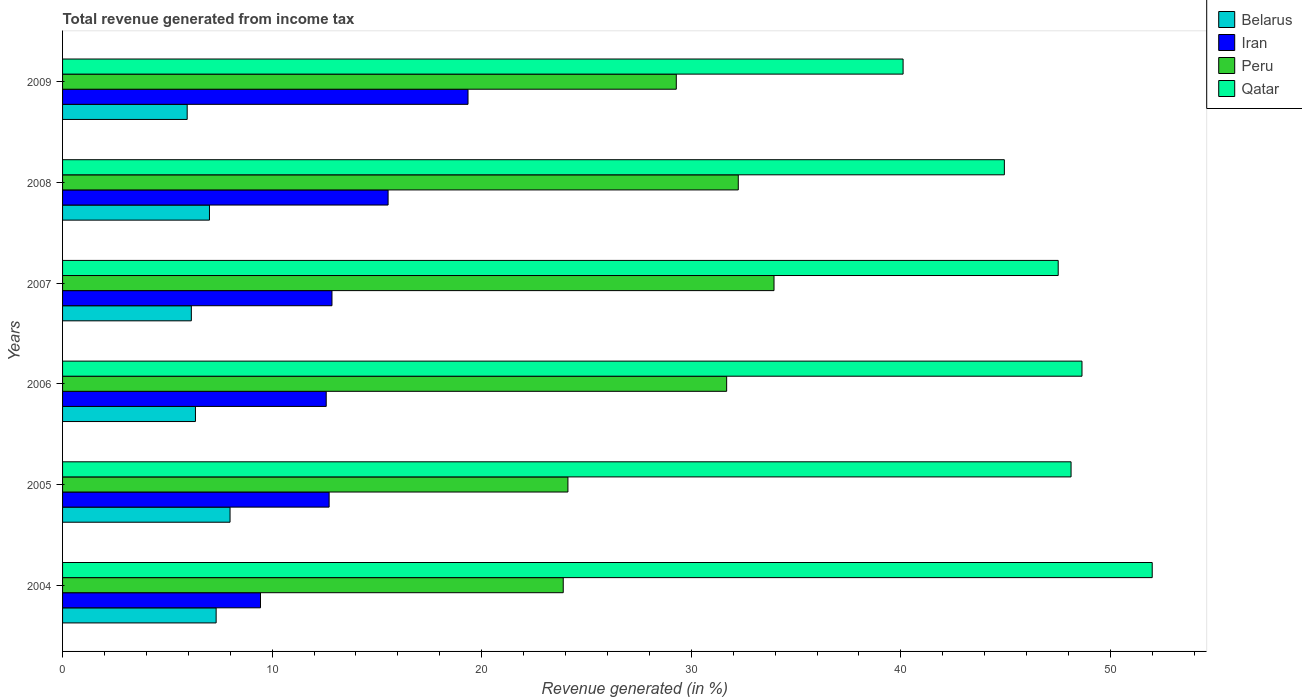How many different coloured bars are there?
Keep it short and to the point. 4. Are the number of bars on each tick of the Y-axis equal?
Provide a short and direct response. Yes. How many bars are there on the 5th tick from the bottom?
Your answer should be compact. 4. In how many cases, is the number of bars for a given year not equal to the number of legend labels?
Provide a succinct answer. 0. What is the total revenue generated in Qatar in 2007?
Provide a short and direct response. 47.51. Across all years, what is the maximum total revenue generated in Peru?
Your response must be concise. 33.95. Across all years, what is the minimum total revenue generated in Iran?
Provide a succinct answer. 9.45. In which year was the total revenue generated in Belarus minimum?
Give a very brief answer. 2009. What is the total total revenue generated in Iran in the graph?
Provide a short and direct response. 82.48. What is the difference between the total revenue generated in Qatar in 2007 and that in 2008?
Make the answer very short. 2.57. What is the difference between the total revenue generated in Peru in 2006 and the total revenue generated in Belarus in 2009?
Ensure brevity in your answer.  25.74. What is the average total revenue generated in Qatar per year?
Offer a terse response. 46.89. In the year 2006, what is the difference between the total revenue generated in Peru and total revenue generated in Belarus?
Offer a very short reply. 25.35. In how many years, is the total revenue generated in Iran greater than 12 %?
Your answer should be compact. 5. What is the ratio of the total revenue generated in Iran in 2004 to that in 2006?
Ensure brevity in your answer.  0.75. What is the difference between the highest and the second highest total revenue generated in Peru?
Offer a very short reply. 1.71. What is the difference between the highest and the lowest total revenue generated in Qatar?
Make the answer very short. 11.89. In how many years, is the total revenue generated in Belarus greater than the average total revenue generated in Belarus taken over all years?
Keep it short and to the point. 3. Is it the case that in every year, the sum of the total revenue generated in Peru and total revenue generated in Qatar is greater than the sum of total revenue generated in Iran and total revenue generated in Belarus?
Ensure brevity in your answer.  Yes. What does the 2nd bar from the top in 2006 represents?
Offer a very short reply. Peru. How many bars are there?
Keep it short and to the point. 24. Are all the bars in the graph horizontal?
Your answer should be compact. Yes. What is the difference between two consecutive major ticks on the X-axis?
Your answer should be compact. 10. Are the values on the major ticks of X-axis written in scientific E-notation?
Keep it short and to the point. No. Does the graph contain grids?
Your response must be concise. No. Where does the legend appear in the graph?
Your answer should be compact. Top right. What is the title of the graph?
Make the answer very short. Total revenue generated from income tax. Does "Togo" appear as one of the legend labels in the graph?
Provide a succinct answer. No. What is the label or title of the X-axis?
Keep it short and to the point. Revenue generated (in %). What is the Revenue generated (in %) of Belarus in 2004?
Your answer should be very brief. 7.33. What is the Revenue generated (in %) in Iran in 2004?
Offer a terse response. 9.45. What is the Revenue generated (in %) in Peru in 2004?
Your answer should be very brief. 23.89. What is the Revenue generated (in %) of Qatar in 2004?
Your answer should be compact. 52. What is the Revenue generated (in %) of Belarus in 2005?
Your answer should be very brief. 7.99. What is the Revenue generated (in %) of Iran in 2005?
Provide a succinct answer. 12.72. What is the Revenue generated (in %) of Peru in 2005?
Make the answer very short. 24.11. What is the Revenue generated (in %) in Qatar in 2005?
Your response must be concise. 48.12. What is the Revenue generated (in %) in Belarus in 2006?
Make the answer very short. 6.34. What is the Revenue generated (in %) in Iran in 2006?
Provide a succinct answer. 12.58. What is the Revenue generated (in %) in Peru in 2006?
Your response must be concise. 31.69. What is the Revenue generated (in %) of Qatar in 2006?
Keep it short and to the point. 48.64. What is the Revenue generated (in %) in Belarus in 2007?
Your response must be concise. 6.15. What is the Revenue generated (in %) of Iran in 2007?
Make the answer very short. 12.86. What is the Revenue generated (in %) of Peru in 2007?
Offer a very short reply. 33.95. What is the Revenue generated (in %) in Qatar in 2007?
Your answer should be very brief. 47.51. What is the Revenue generated (in %) in Belarus in 2008?
Ensure brevity in your answer.  7.01. What is the Revenue generated (in %) in Iran in 2008?
Offer a terse response. 15.53. What is the Revenue generated (in %) of Peru in 2008?
Your answer should be compact. 32.24. What is the Revenue generated (in %) of Qatar in 2008?
Provide a short and direct response. 44.94. What is the Revenue generated (in %) in Belarus in 2009?
Provide a succinct answer. 5.95. What is the Revenue generated (in %) of Iran in 2009?
Offer a terse response. 19.35. What is the Revenue generated (in %) of Peru in 2009?
Your answer should be compact. 29.29. What is the Revenue generated (in %) in Qatar in 2009?
Your answer should be very brief. 40.11. Across all years, what is the maximum Revenue generated (in %) of Belarus?
Keep it short and to the point. 7.99. Across all years, what is the maximum Revenue generated (in %) of Iran?
Your response must be concise. 19.35. Across all years, what is the maximum Revenue generated (in %) in Peru?
Offer a terse response. 33.95. Across all years, what is the maximum Revenue generated (in %) of Qatar?
Ensure brevity in your answer.  52. Across all years, what is the minimum Revenue generated (in %) in Belarus?
Keep it short and to the point. 5.95. Across all years, what is the minimum Revenue generated (in %) in Iran?
Give a very brief answer. 9.45. Across all years, what is the minimum Revenue generated (in %) in Peru?
Ensure brevity in your answer.  23.89. Across all years, what is the minimum Revenue generated (in %) of Qatar?
Your answer should be compact. 40.11. What is the total Revenue generated (in %) in Belarus in the graph?
Ensure brevity in your answer.  40.76. What is the total Revenue generated (in %) in Iran in the graph?
Ensure brevity in your answer.  82.48. What is the total Revenue generated (in %) of Peru in the graph?
Make the answer very short. 175.17. What is the total Revenue generated (in %) in Qatar in the graph?
Ensure brevity in your answer.  281.32. What is the difference between the Revenue generated (in %) of Belarus in 2004 and that in 2005?
Provide a short and direct response. -0.66. What is the difference between the Revenue generated (in %) in Iran in 2004 and that in 2005?
Keep it short and to the point. -3.27. What is the difference between the Revenue generated (in %) in Peru in 2004 and that in 2005?
Ensure brevity in your answer.  -0.22. What is the difference between the Revenue generated (in %) in Qatar in 2004 and that in 2005?
Give a very brief answer. 3.87. What is the difference between the Revenue generated (in %) of Belarus in 2004 and that in 2006?
Your answer should be compact. 0.99. What is the difference between the Revenue generated (in %) in Iran in 2004 and that in 2006?
Offer a terse response. -3.14. What is the difference between the Revenue generated (in %) in Peru in 2004 and that in 2006?
Provide a short and direct response. -7.8. What is the difference between the Revenue generated (in %) in Qatar in 2004 and that in 2006?
Keep it short and to the point. 3.35. What is the difference between the Revenue generated (in %) of Belarus in 2004 and that in 2007?
Offer a very short reply. 1.18. What is the difference between the Revenue generated (in %) of Iran in 2004 and that in 2007?
Ensure brevity in your answer.  -3.41. What is the difference between the Revenue generated (in %) of Peru in 2004 and that in 2007?
Give a very brief answer. -10.06. What is the difference between the Revenue generated (in %) in Qatar in 2004 and that in 2007?
Your response must be concise. 4.49. What is the difference between the Revenue generated (in %) of Belarus in 2004 and that in 2008?
Keep it short and to the point. 0.32. What is the difference between the Revenue generated (in %) in Iran in 2004 and that in 2008?
Offer a very short reply. -6.09. What is the difference between the Revenue generated (in %) in Peru in 2004 and that in 2008?
Keep it short and to the point. -8.35. What is the difference between the Revenue generated (in %) in Qatar in 2004 and that in 2008?
Ensure brevity in your answer.  7.06. What is the difference between the Revenue generated (in %) in Belarus in 2004 and that in 2009?
Ensure brevity in your answer.  1.38. What is the difference between the Revenue generated (in %) of Iran in 2004 and that in 2009?
Your answer should be compact. -9.9. What is the difference between the Revenue generated (in %) of Peru in 2004 and that in 2009?
Offer a terse response. -5.4. What is the difference between the Revenue generated (in %) in Qatar in 2004 and that in 2009?
Ensure brevity in your answer.  11.89. What is the difference between the Revenue generated (in %) in Belarus in 2005 and that in 2006?
Make the answer very short. 1.65. What is the difference between the Revenue generated (in %) of Iran in 2005 and that in 2006?
Your response must be concise. 0.14. What is the difference between the Revenue generated (in %) in Peru in 2005 and that in 2006?
Provide a short and direct response. -7.57. What is the difference between the Revenue generated (in %) of Qatar in 2005 and that in 2006?
Provide a succinct answer. -0.52. What is the difference between the Revenue generated (in %) of Belarus in 2005 and that in 2007?
Provide a succinct answer. 1.85. What is the difference between the Revenue generated (in %) in Iran in 2005 and that in 2007?
Offer a very short reply. -0.14. What is the difference between the Revenue generated (in %) of Peru in 2005 and that in 2007?
Provide a succinct answer. -9.83. What is the difference between the Revenue generated (in %) in Qatar in 2005 and that in 2007?
Provide a short and direct response. 0.61. What is the difference between the Revenue generated (in %) in Belarus in 2005 and that in 2008?
Offer a very short reply. 0.98. What is the difference between the Revenue generated (in %) in Iran in 2005 and that in 2008?
Offer a very short reply. -2.81. What is the difference between the Revenue generated (in %) in Peru in 2005 and that in 2008?
Provide a short and direct response. -8.13. What is the difference between the Revenue generated (in %) of Qatar in 2005 and that in 2008?
Offer a very short reply. 3.18. What is the difference between the Revenue generated (in %) in Belarus in 2005 and that in 2009?
Offer a very short reply. 2.04. What is the difference between the Revenue generated (in %) of Iran in 2005 and that in 2009?
Provide a succinct answer. -6.63. What is the difference between the Revenue generated (in %) in Peru in 2005 and that in 2009?
Make the answer very short. -5.17. What is the difference between the Revenue generated (in %) in Qatar in 2005 and that in 2009?
Ensure brevity in your answer.  8.02. What is the difference between the Revenue generated (in %) in Belarus in 2006 and that in 2007?
Offer a very short reply. 0.2. What is the difference between the Revenue generated (in %) of Iran in 2006 and that in 2007?
Provide a succinct answer. -0.27. What is the difference between the Revenue generated (in %) of Peru in 2006 and that in 2007?
Provide a short and direct response. -2.26. What is the difference between the Revenue generated (in %) in Qatar in 2006 and that in 2007?
Offer a terse response. 1.13. What is the difference between the Revenue generated (in %) of Belarus in 2006 and that in 2008?
Provide a short and direct response. -0.67. What is the difference between the Revenue generated (in %) in Iran in 2006 and that in 2008?
Give a very brief answer. -2.95. What is the difference between the Revenue generated (in %) in Peru in 2006 and that in 2008?
Keep it short and to the point. -0.55. What is the difference between the Revenue generated (in %) in Qatar in 2006 and that in 2008?
Ensure brevity in your answer.  3.7. What is the difference between the Revenue generated (in %) of Belarus in 2006 and that in 2009?
Your response must be concise. 0.39. What is the difference between the Revenue generated (in %) in Iran in 2006 and that in 2009?
Provide a short and direct response. -6.77. What is the difference between the Revenue generated (in %) in Peru in 2006 and that in 2009?
Offer a terse response. 2.4. What is the difference between the Revenue generated (in %) in Qatar in 2006 and that in 2009?
Your answer should be compact. 8.54. What is the difference between the Revenue generated (in %) in Belarus in 2007 and that in 2008?
Keep it short and to the point. -0.87. What is the difference between the Revenue generated (in %) in Iran in 2007 and that in 2008?
Keep it short and to the point. -2.68. What is the difference between the Revenue generated (in %) in Peru in 2007 and that in 2008?
Offer a terse response. 1.71. What is the difference between the Revenue generated (in %) in Qatar in 2007 and that in 2008?
Offer a terse response. 2.57. What is the difference between the Revenue generated (in %) in Belarus in 2007 and that in 2009?
Your answer should be compact. 0.2. What is the difference between the Revenue generated (in %) of Iran in 2007 and that in 2009?
Provide a succinct answer. -6.49. What is the difference between the Revenue generated (in %) of Peru in 2007 and that in 2009?
Your answer should be very brief. 4.66. What is the difference between the Revenue generated (in %) of Qatar in 2007 and that in 2009?
Give a very brief answer. 7.4. What is the difference between the Revenue generated (in %) in Belarus in 2008 and that in 2009?
Your response must be concise. 1.06. What is the difference between the Revenue generated (in %) in Iran in 2008 and that in 2009?
Your response must be concise. -3.81. What is the difference between the Revenue generated (in %) of Peru in 2008 and that in 2009?
Ensure brevity in your answer.  2.96. What is the difference between the Revenue generated (in %) of Qatar in 2008 and that in 2009?
Offer a terse response. 4.83. What is the difference between the Revenue generated (in %) of Belarus in 2004 and the Revenue generated (in %) of Iran in 2005?
Offer a terse response. -5.39. What is the difference between the Revenue generated (in %) of Belarus in 2004 and the Revenue generated (in %) of Peru in 2005?
Provide a short and direct response. -16.79. What is the difference between the Revenue generated (in %) in Belarus in 2004 and the Revenue generated (in %) in Qatar in 2005?
Your response must be concise. -40.8. What is the difference between the Revenue generated (in %) in Iran in 2004 and the Revenue generated (in %) in Peru in 2005?
Make the answer very short. -14.67. What is the difference between the Revenue generated (in %) of Iran in 2004 and the Revenue generated (in %) of Qatar in 2005?
Make the answer very short. -38.68. What is the difference between the Revenue generated (in %) of Peru in 2004 and the Revenue generated (in %) of Qatar in 2005?
Your response must be concise. -24.23. What is the difference between the Revenue generated (in %) in Belarus in 2004 and the Revenue generated (in %) in Iran in 2006?
Offer a terse response. -5.25. What is the difference between the Revenue generated (in %) of Belarus in 2004 and the Revenue generated (in %) of Peru in 2006?
Ensure brevity in your answer.  -24.36. What is the difference between the Revenue generated (in %) in Belarus in 2004 and the Revenue generated (in %) in Qatar in 2006?
Provide a short and direct response. -41.32. What is the difference between the Revenue generated (in %) in Iran in 2004 and the Revenue generated (in %) in Peru in 2006?
Your answer should be compact. -22.24. What is the difference between the Revenue generated (in %) of Iran in 2004 and the Revenue generated (in %) of Qatar in 2006?
Offer a terse response. -39.2. What is the difference between the Revenue generated (in %) in Peru in 2004 and the Revenue generated (in %) in Qatar in 2006?
Make the answer very short. -24.75. What is the difference between the Revenue generated (in %) in Belarus in 2004 and the Revenue generated (in %) in Iran in 2007?
Offer a terse response. -5.53. What is the difference between the Revenue generated (in %) in Belarus in 2004 and the Revenue generated (in %) in Peru in 2007?
Give a very brief answer. -26.62. What is the difference between the Revenue generated (in %) of Belarus in 2004 and the Revenue generated (in %) of Qatar in 2007?
Provide a succinct answer. -40.18. What is the difference between the Revenue generated (in %) of Iran in 2004 and the Revenue generated (in %) of Peru in 2007?
Your answer should be very brief. -24.5. What is the difference between the Revenue generated (in %) in Iran in 2004 and the Revenue generated (in %) in Qatar in 2007?
Ensure brevity in your answer.  -38.07. What is the difference between the Revenue generated (in %) of Peru in 2004 and the Revenue generated (in %) of Qatar in 2007?
Provide a succinct answer. -23.62. What is the difference between the Revenue generated (in %) in Belarus in 2004 and the Revenue generated (in %) in Iran in 2008?
Provide a short and direct response. -8.21. What is the difference between the Revenue generated (in %) in Belarus in 2004 and the Revenue generated (in %) in Peru in 2008?
Offer a very short reply. -24.92. What is the difference between the Revenue generated (in %) in Belarus in 2004 and the Revenue generated (in %) in Qatar in 2008?
Offer a terse response. -37.61. What is the difference between the Revenue generated (in %) of Iran in 2004 and the Revenue generated (in %) of Peru in 2008?
Provide a short and direct response. -22.8. What is the difference between the Revenue generated (in %) of Iran in 2004 and the Revenue generated (in %) of Qatar in 2008?
Your answer should be compact. -35.5. What is the difference between the Revenue generated (in %) of Peru in 2004 and the Revenue generated (in %) of Qatar in 2008?
Provide a succinct answer. -21.05. What is the difference between the Revenue generated (in %) in Belarus in 2004 and the Revenue generated (in %) in Iran in 2009?
Your answer should be very brief. -12.02. What is the difference between the Revenue generated (in %) of Belarus in 2004 and the Revenue generated (in %) of Peru in 2009?
Your response must be concise. -21.96. What is the difference between the Revenue generated (in %) of Belarus in 2004 and the Revenue generated (in %) of Qatar in 2009?
Offer a very short reply. -32.78. What is the difference between the Revenue generated (in %) in Iran in 2004 and the Revenue generated (in %) in Peru in 2009?
Make the answer very short. -19.84. What is the difference between the Revenue generated (in %) of Iran in 2004 and the Revenue generated (in %) of Qatar in 2009?
Your answer should be compact. -30.66. What is the difference between the Revenue generated (in %) in Peru in 2004 and the Revenue generated (in %) in Qatar in 2009?
Offer a very short reply. -16.22. What is the difference between the Revenue generated (in %) in Belarus in 2005 and the Revenue generated (in %) in Iran in 2006?
Provide a succinct answer. -4.59. What is the difference between the Revenue generated (in %) of Belarus in 2005 and the Revenue generated (in %) of Peru in 2006?
Provide a short and direct response. -23.7. What is the difference between the Revenue generated (in %) in Belarus in 2005 and the Revenue generated (in %) in Qatar in 2006?
Provide a succinct answer. -40.65. What is the difference between the Revenue generated (in %) in Iran in 2005 and the Revenue generated (in %) in Peru in 2006?
Keep it short and to the point. -18.97. What is the difference between the Revenue generated (in %) in Iran in 2005 and the Revenue generated (in %) in Qatar in 2006?
Your answer should be very brief. -35.92. What is the difference between the Revenue generated (in %) in Peru in 2005 and the Revenue generated (in %) in Qatar in 2006?
Provide a succinct answer. -24.53. What is the difference between the Revenue generated (in %) in Belarus in 2005 and the Revenue generated (in %) in Iran in 2007?
Provide a succinct answer. -4.86. What is the difference between the Revenue generated (in %) of Belarus in 2005 and the Revenue generated (in %) of Peru in 2007?
Give a very brief answer. -25.96. What is the difference between the Revenue generated (in %) in Belarus in 2005 and the Revenue generated (in %) in Qatar in 2007?
Your answer should be compact. -39.52. What is the difference between the Revenue generated (in %) in Iran in 2005 and the Revenue generated (in %) in Peru in 2007?
Provide a short and direct response. -21.23. What is the difference between the Revenue generated (in %) of Iran in 2005 and the Revenue generated (in %) of Qatar in 2007?
Keep it short and to the point. -34.79. What is the difference between the Revenue generated (in %) of Peru in 2005 and the Revenue generated (in %) of Qatar in 2007?
Offer a terse response. -23.4. What is the difference between the Revenue generated (in %) of Belarus in 2005 and the Revenue generated (in %) of Iran in 2008?
Ensure brevity in your answer.  -7.54. What is the difference between the Revenue generated (in %) of Belarus in 2005 and the Revenue generated (in %) of Peru in 2008?
Make the answer very short. -24.25. What is the difference between the Revenue generated (in %) of Belarus in 2005 and the Revenue generated (in %) of Qatar in 2008?
Make the answer very short. -36.95. What is the difference between the Revenue generated (in %) of Iran in 2005 and the Revenue generated (in %) of Peru in 2008?
Ensure brevity in your answer.  -19.52. What is the difference between the Revenue generated (in %) of Iran in 2005 and the Revenue generated (in %) of Qatar in 2008?
Ensure brevity in your answer.  -32.22. What is the difference between the Revenue generated (in %) in Peru in 2005 and the Revenue generated (in %) in Qatar in 2008?
Your response must be concise. -20.83. What is the difference between the Revenue generated (in %) of Belarus in 2005 and the Revenue generated (in %) of Iran in 2009?
Keep it short and to the point. -11.36. What is the difference between the Revenue generated (in %) in Belarus in 2005 and the Revenue generated (in %) in Peru in 2009?
Your response must be concise. -21.29. What is the difference between the Revenue generated (in %) of Belarus in 2005 and the Revenue generated (in %) of Qatar in 2009?
Provide a succinct answer. -32.12. What is the difference between the Revenue generated (in %) of Iran in 2005 and the Revenue generated (in %) of Peru in 2009?
Ensure brevity in your answer.  -16.57. What is the difference between the Revenue generated (in %) of Iran in 2005 and the Revenue generated (in %) of Qatar in 2009?
Provide a succinct answer. -27.39. What is the difference between the Revenue generated (in %) of Peru in 2005 and the Revenue generated (in %) of Qatar in 2009?
Ensure brevity in your answer.  -15.99. What is the difference between the Revenue generated (in %) of Belarus in 2006 and the Revenue generated (in %) of Iran in 2007?
Ensure brevity in your answer.  -6.51. What is the difference between the Revenue generated (in %) in Belarus in 2006 and the Revenue generated (in %) in Peru in 2007?
Give a very brief answer. -27.61. What is the difference between the Revenue generated (in %) in Belarus in 2006 and the Revenue generated (in %) in Qatar in 2007?
Your answer should be compact. -41.17. What is the difference between the Revenue generated (in %) of Iran in 2006 and the Revenue generated (in %) of Peru in 2007?
Give a very brief answer. -21.37. What is the difference between the Revenue generated (in %) of Iran in 2006 and the Revenue generated (in %) of Qatar in 2007?
Your answer should be very brief. -34.93. What is the difference between the Revenue generated (in %) of Peru in 2006 and the Revenue generated (in %) of Qatar in 2007?
Give a very brief answer. -15.82. What is the difference between the Revenue generated (in %) of Belarus in 2006 and the Revenue generated (in %) of Iran in 2008?
Your response must be concise. -9.19. What is the difference between the Revenue generated (in %) of Belarus in 2006 and the Revenue generated (in %) of Peru in 2008?
Your answer should be very brief. -25.9. What is the difference between the Revenue generated (in %) in Belarus in 2006 and the Revenue generated (in %) in Qatar in 2008?
Provide a succinct answer. -38.6. What is the difference between the Revenue generated (in %) in Iran in 2006 and the Revenue generated (in %) in Peru in 2008?
Your answer should be very brief. -19.66. What is the difference between the Revenue generated (in %) in Iran in 2006 and the Revenue generated (in %) in Qatar in 2008?
Your response must be concise. -32.36. What is the difference between the Revenue generated (in %) in Peru in 2006 and the Revenue generated (in %) in Qatar in 2008?
Make the answer very short. -13.25. What is the difference between the Revenue generated (in %) of Belarus in 2006 and the Revenue generated (in %) of Iran in 2009?
Make the answer very short. -13.01. What is the difference between the Revenue generated (in %) of Belarus in 2006 and the Revenue generated (in %) of Peru in 2009?
Your answer should be very brief. -22.94. What is the difference between the Revenue generated (in %) in Belarus in 2006 and the Revenue generated (in %) in Qatar in 2009?
Offer a terse response. -33.77. What is the difference between the Revenue generated (in %) in Iran in 2006 and the Revenue generated (in %) in Peru in 2009?
Provide a short and direct response. -16.71. What is the difference between the Revenue generated (in %) in Iran in 2006 and the Revenue generated (in %) in Qatar in 2009?
Your response must be concise. -27.53. What is the difference between the Revenue generated (in %) of Peru in 2006 and the Revenue generated (in %) of Qatar in 2009?
Provide a short and direct response. -8.42. What is the difference between the Revenue generated (in %) in Belarus in 2007 and the Revenue generated (in %) in Iran in 2008?
Your answer should be compact. -9.39. What is the difference between the Revenue generated (in %) of Belarus in 2007 and the Revenue generated (in %) of Peru in 2008?
Your answer should be very brief. -26.1. What is the difference between the Revenue generated (in %) in Belarus in 2007 and the Revenue generated (in %) in Qatar in 2008?
Ensure brevity in your answer.  -38.8. What is the difference between the Revenue generated (in %) of Iran in 2007 and the Revenue generated (in %) of Peru in 2008?
Provide a short and direct response. -19.39. What is the difference between the Revenue generated (in %) in Iran in 2007 and the Revenue generated (in %) in Qatar in 2008?
Give a very brief answer. -32.09. What is the difference between the Revenue generated (in %) of Peru in 2007 and the Revenue generated (in %) of Qatar in 2008?
Give a very brief answer. -10.99. What is the difference between the Revenue generated (in %) in Belarus in 2007 and the Revenue generated (in %) in Iran in 2009?
Your answer should be very brief. -13.2. What is the difference between the Revenue generated (in %) of Belarus in 2007 and the Revenue generated (in %) of Peru in 2009?
Give a very brief answer. -23.14. What is the difference between the Revenue generated (in %) of Belarus in 2007 and the Revenue generated (in %) of Qatar in 2009?
Your response must be concise. -33.96. What is the difference between the Revenue generated (in %) in Iran in 2007 and the Revenue generated (in %) in Peru in 2009?
Your answer should be very brief. -16.43. What is the difference between the Revenue generated (in %) in Iran in 2007 and the Revenue generated (in %) in Qatar in 2009?
Offer a very short reply. -27.25. What is the difference between the Revenue generated (in %) in Peru in 2007 and the Revenue generated (in %) in Qatar in 2009?
Your answer should be very brief. -6.16. What is the difference between the Revenue generated (in %) in Belarus in 2008 and the Revenue generated (in %) in Iran in 2009?
Your response must be concise. -12.34. What is the difference between the Revenue generated (in %) of Belarus in 2008 and the Revenue generated (in %) of Peru in 2009?
Offer a terse response. -22.28. What is the difference between the Revenue generated (in %) in Belarus in 2008 and the Revenue generated (in %) in Qatar in 2009?
Keep it short and to the point. -33.1. What is the difference between the Revenue generated (in %) of Iran in 2008 and the Revenue generated (in %) of Peru in 2009?
Make the answer very short. -13.75. What is the difference between the Revenue generated (in %) in Iran in 2008 and the Revenue generated (in %) in Qatar in 2009?
Provide a short and direct response. -24.57. What is the difference between the Revenue generated (in %) of Peru in 2008 and the Revenue generated (in %) of Qatar in 2009?
Provide a short and direct response. -7.86. What is the average Revenue generated (in %) of Belarus per year?
Offer a very short reply. 6.79. What is the average Revenue generated (in %) in Iran per year?
Keep it short and to the point. 13.75. What is the average Revenue generated (in %) in Peru per year?
Make the answer very short. 29.2. What is the average Revenue generated (in %) in Qatar per year?
Give a very brief answer. 46.89. In the year 2004, what is the difference between the Revenue generated (in %) in Belarus and Revenue generated (in %) in Iran?
Your response must be concise. -2.12. In the year 2004, what is the difference between the Revenue generated (in %) in Belarus and Revenue generated (in %) in Peru?
Your response must be concise. -16.56. In the year 2004, what is the difference between the Revenue generated (in %) in Belarus and Revenue generated (in %) in Qatar?
Your answer should be compact. -44.67. In the year 2004, what is the difference between the Revenue generated (in %) of Iran and Revenue generated (in %) of Peru?
Provide a succinct answer. -14.45. In the year 2004, what is the difference between the Revenue generated (in %) in Iran and Revenue generated (in %) in Qatar?
Provide a short and direct response. -42.55. In the year 2004, what is the difference between the Revenue generated (in %) in Peru and Revenue generated (in %) in Qatar?
Your answer should be compact. -28.1. In the year 2005, what is the difference between the Revenue generated (in %) of Belarus and Revenue generated (in %) of Iran?
Offer a terse response. -4.73. In the year 2005, what is the difference between the Revenue generated (in %) in Belarus and Revenue generated (in %) in Peru?
Ensure brevity in your answer.  -16.12. In the year 2005, what is the difference between the Revenue generated (in %) in Belarus and Revenue generated (in %) in Qatar?
Your answer should be compact. -40.13. In the year 2005, what is the difference between the Revenue generated (in %) in Iran and Revenue generated (in %) in Peru?
Your answer should be compact. -11.39. In the year 2005, what is the difference between the Revenue generated (in %) of Iran and Revenue generated (in %) of Qatar?
Provide a short and direct response. -35.4. In the year 2005, what is the difference between the Revenue generated (in %) of Peru and Revenue generated (in %) of Qatar?
Provide a succinct answer. -24.01. In the year 2006, what is the difference between the Revenue generated (in %) of Belarus and Revenue generated (in %) of Iran?
Ensure brevity in your answer.  -6.24. In the year 2006, what is the difference between the Revenue generated (in %) of Belarus and Revenue generated (in %) of Peru?
Give a very brief answer. -25.35. In the year 2006, what is the difference between the Revenue generated (in %) in Belarus and Revenue generated (in %) in Qatar?
Offer a very short reply. -42.3. In the year 2006, what is the difference between the Revenue generated (in %) of Iran and Revenue generated (in %) of Peru?
Provide a succinct answer. -19.11. In the year 2006, what is the difference between the Revenue generated (in %) of Iran and Revenue generated (in %) of Qatar?
Give a very brief answer. -36.06. In the year 2006, what is the difference between the Revenue generated (in %) of Peru and Revenue generated (in %) of Qatar?
Provide a short and direct response. -16.96. In the year 2007, what is the difference between the Revenue generated (in %) in Belarus and Revenue generated (in %) in Iran?
Ensure brevity in your answer.  -6.71. In the year 2007, what is the difference between the Revenue generated (in %) of Belarus and Revenue generated (in %) of Peru?
Your answer should be very brief. -27.8. In the year 2007, what is the difference between the Revenue generated (in %) in Belarus and Revenue generated (in %) in Qatar?
Your answer should be compact. -41.37. In the year 2007, what is the difference between the Revenue generated (in %) in Iran and Revenue generated (in %) in Peru?
Your answer should be very brief. -21.09. In the year 2007, what is the difference between the Revenue generated (in %) of Iran and Revenue generated (in %) of Qatar?
Keep it short and to the point. -34.66. In the year 2007, what is the difference between the Revenue generated (in %) of Peru and Revenue generated (in %) of Qatar?
Your answer should be compact. -13.56. In the year 2008, what is the difference between the Revenue generated (in %) in Belarus and Revenue generated (in %) in Iran?
Make the answer very short. -8.52. In the year 2008, what is the difference between the Revenue generated (in %) in Belarus and Revenue generated (in %) in Peru?
Your answer should be compact. -25.23. In the year 2008, what is the difference between the Revenue generated (in %) in Belarus and Revenue generated (in %) in Qatar?
Ensure brevity in your answer.  -37.93. In the year 2008, what is the difference between the Revenue generated (in %) in Iran and Revenue generated (in %) in Peru?
Provide a short and direct response. -16.71. In the year 2008, what is the difference between the Revenue generated (in %) of Iran and Revenue generated (in %) of Qatar?
Keep it short and to the point. -29.41. In the year 2008, what is the difference between the Revenue generated (in %) of Peru and Revenue generated (in %) of Qatar?
Offer a very short reply. -12.7. In the year 2009, what is the difference between the Revenue generated (in %) of Belarus and Revenue generated (in %) of Iran?
Your response must be concise. -13.4. In the year 2009, what is the difference between the Revenue generated (in %) in Belarus and Revenue generated (in %) in Peru?
Your response must be concise. -23.34. In the year 2009, what is the difference between the Revenue generated (in %) in Belarus and Revenue generated (in %) in Qatar?
Your answer should be compact. -34.16. In the year 2009, what is the difference between the Revenue generated (in %) in Iran and Revenue generated (in %) in Peru?
Ensure brevity in your answer.  -9.94. In the year 2009, what is the difference between the Revenue generated (in %) in Iran and Revenue generated (in %) in Qatar?
Your response must be concise. -20.76. In the year 2009, what is the difference between the Revenue generated (in %) in Peru and Revenue generated (in %) in Qatar?
Give a very brief answer. -10.82. What is the ratio of the Revenue generated (in %) in Belarus in 2004 to that in 2005?
Keep it short and to the point. 0.92. What is the ratio of the Revenue generated (in %) in Iran in 2004 to that in 2005?
Give a very brief answer. 0.74. What is the ratio of the Revenue generated (in %) of Peru in 2004 to that in 2005?
Your answer should be very brief. 0.99. What is the ratio of the Revenue generated (in %) of Qatar in 2004 to that in 2005?
Provide a succinct answer. 1.08. What is the ratio of the Revenue generated (in %) of Belarus in 2004 to that in 2006?
Offer a terse response. 1.16. What is the ratio of the Revenue generated (in %) in Iran in 2004 to that in 2006?
Provide a short and direct response. 0.75. What is the ratio of the Revenue generated (in %) in Peru in 2004 to that in 2006?
Your answer should be very brief. 0.75. What is the ratio of the Revenue generated (in %) of Qatar in 2004 to that in 2006?
Give a very brief answer. 1.07. What is the ratio of the Revenue generated (in %) of Belarus in 2004 to that in 2007?
Your answer should be compact. 1.19. What is the ratio of the Revenue generated (in %) in Iran in 2004 to that in 2007?
Keep it short and to the point. 0.73. What is the ratio of the Revenue generated (in %) of Peru in 2004 to that in 2007?
Offer a very short reply. 0.7. What is the ratio of the Revenue generated (in %) in Qatar in 2004 to that in 2007?
Give a very brief answer. 1.09. What is the ratio of the Revenue generated (in %) of Belarus in 2004 to that in 2008?
Provide a short and direct response. 1.05. What is the ratio of the Revenue generated (in %) of Iran in 2004 to that in 2008?
Offer a very short reply. 0.61. What is the ratio of the Revenue generated (in %) of Peru in 2004 to that in 2008?
Offer a very short reply. 0.74. What is the ratio of the Revenue generated (in %) of Qatar in 2004 to that in 2008?
Keep it short and to the point. 1.16. What is the ratio of the Revenue generated (in %) in Belarus in 2004 to that in 2009?
Your answer should be compact. 1.23. What is the ratio of the Revenue generated (in %) in Iran in 2004 to that in 2009?
Offer a very short reply. 0.49. What is the ratio of the Revenue generated (in %) in Peru in 2004 to that in 2009?
Your answer should be very brief. 0.82. What is the ratio of the Revenue generated (in %) of Qatar in 2004 to that in 2009?
Give a very brief answer. 1.3. What is the ratio of the Revenue generated (in %) of Belarus in 2005 to that in 2006?
Make the answer very short. 1.26. What is the ratio of the Revenue generated (in %) in Iran in 2005 to that in 2006?
Give a very brief answer. 1.01. What is the ratio of the Revenue generated (in %) of Peru in 2005 to that in 2006?
Your response must be concise. 0.76. What is the ratio of the Revenue generated (in %) in Qatar in 2005 to that in 2006?
Keep it short and to the point. 0.99. What is the ratio of the Revenue generated (in %) in Belarus in 2005 to that in 2007?
Give a very brief answer. 1.3. What is the ratio of the Revenue generated (in %) in Iran in 2005 to that in 2007?
Offer a terse response. 0.99. What is the ratio of the Revenue generated (in %) in Peru in 2005 to that in 2007?
Offer a very short reply. 0.71. What is the ratio of the Revenue generated (in %) of Qatar in 2005 to that in 2007?
Your answer should be very brief. 1.01. What is the ratio of the Revenue generated (in %) in Belarus in 2005 to that in 2008?
Ensure brevity in your answer.  1.14. What is the ratio of the Revenue generated (in %) of Iran in 2005 to that in 2008?
Your answer should be very brief. 0.82. What is the ratio of the Revenue generated (in %) in Peru in 2005 to that in 2008?
Provide a short and direct response. 0.75. What is the ratio of the Revenue generated (in %) in Qatar in 2005 to that in 2008?
Your answer should be very brief. 1.07. What is the ratio of the Revenue generated (in %) of Belarus in 2005 to that in 2009?
Offer a very short reply. 1.34. What is the ratio of the Revenue generated (in %) of Iran in 2005 to that in 2009?
Your response must be concise. 0.66. What is the ratio of the Revenue generated (in %) in Peru in 2005 to that in 2009?
Offer a very short reply. 0.82. What is the ratio of the Revenue generated (in %) of Qatar in 2005 to that in 2009?
Provide a short and direct response. 1.2. What is the ratio of the Revenue generated (in %) of Belarus in 2006 to that in 2007?
Offer a terse response. 1.03. What is the ratio of the Revenue generated (in %) of Iran in 2006 to that in 2007?
Ensure brevity in your answer.  0.98. What is the ratio of the Revenue generated (in %) of Peru in 2006 to that in 2007?
Your answer should be very brief. 0.93. What is the ratio of the Revenue generated (in %) of Qatar in 2006 to that in 2007?
Offer a very short reply. 1.02. What is the ratio of the Revenue generated (in %) of Belarus in 2006 to that in 2008?
Ensure brevity in your answer.  0.9. What is the ratio of the Revenue generated (in %) in Iran in 2006 to that in 2008?
Offer a very short reply. 0.81. What is the ratio of the Revenue generated (in %) of Peru in 2006 to that in 2008?
Provide a succinct answer. 0.98. What is the ratio of the Revenue generated (in %) of Qatar in 2006 to that in 2008?
Your answer should be compact. 1.08. What is the ratio of the Revenue generated (in %) in Belarus in 2006 to that in 2009?
Provide a succinct answer. 1.07. What is the ratio of the Revenue generated (in %) of Iran in 2006 to that in 2009?
Your response must be concise. 0.65. What is the ratio of the Revenue generated (in %) in Peru in 2006 to that in 2009?
Your answer should be very brief. 1.08. What is the ratio of the Revenue generated (in %) of Qatar in 2006 to that in 2009?
Make the answer very short. 1.21. What is the ratio of the Revenue generated (in %) in Belarus in 2007 to that in 2008?
Provide a succinct answer. 0.88. What is the ratio of the Revenue generated (in %) of Iran in 2007 to that in 2008?
Provide a succinct answer. 0.83. What is the ratio of the Revenue generated (in %) of Peru in 2007 to that in 2008?
Make the answer very short. 1.05. What is the ratio of the Revenue generated (in %) in Qatar in 2007 to that in 2008?
Your answer should be compact. 1.06. What is the ratio of the Revenue generated (in %) in Belarus in 2007 to that in 2009?
Make the answer very short. 1.03. What is the ratio of the Revenue generated (in %) of Iran in 2007 to that in 2009?
Give a very brief answer. 0.66. What is the ratio of the Revenue generated (in %) of Peru in 2007 to that in 2009?
Keep it short and to the point. 1.16. What is the ratio of the Revenue generated (in %) of Qatar in 2007 to that in 2009?
Your answer should be very brief. 1.18. What is the ratio of the Revenue generated (in %) in Belarus in 2008 to that in 2009?
Offer a very short reply. 1.18. What is the ratio of the Revenue generated (in %) of Iran in 2008 to that in 2009?
Your response must be concise. 0.8. What is the ratio of the Revenue generated (in %) of Peru in 2008 to that in 2009?
Keep it short and to the point. 1.1. What is the ratio of the Revenue generated (in %) of Qatar in 2008 to that in 2009?
Ensure brevity in your answer.  1.12. What is the difference between the highest and the second highest Revenue generated (in %) of Belarus?
Provide a short and direct response. 0.66. What is the difference between the highest and the second highest Revenue generated (in %) of Iran?
Your answer should be compact. 3.81. What is the difference between the highest and the second highest Revenue generated (in %) in Peru?
Your response must be concise. 1.71. What is the difference between the highest and the second highest Revenue generated (in %) of Qatar?
Offer a very short reply. 3.35. What is the difference between the highest and the lowest Revenue generated (in %) in Belarus?
Your answer should be compact. 2.04. What is the difference between the highest and the lowest Revenue generated (in %) in Iran?
Keep it short and to the point. 9.9. What is the difference between the highest and the lowest Revenue generated (in %) of Peru?
Your response must be concise. 10.06. What is the difference between the highest and the lowest Revenue generated (in %) in Qatar?
Keep it short and to the point. 11.89. 